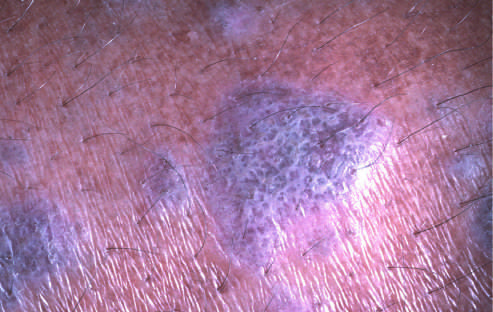what is referred to as wickham striae?
Answer the question using a single word or phrase. Flat-topped pink-purple polygonal papule with white lacelike markings 